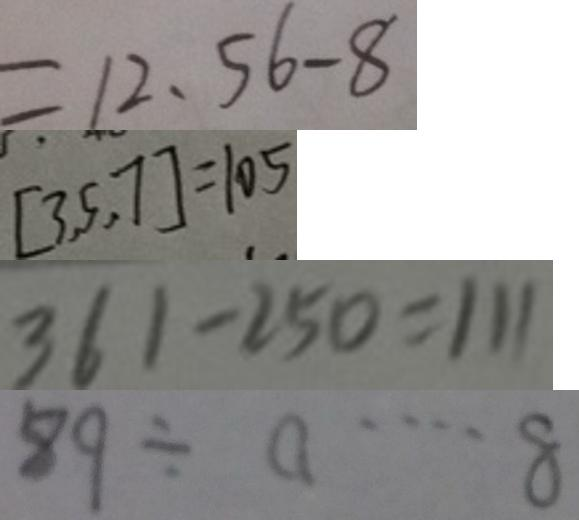<formula> <loc_0><loc_0><loc_500><loc_500>= 1 2 . 5 6 - 8 
 [ 3 , 5 , 7 ] = 1 0 5 
 3 6 1 - 2 5 0 = 1 1 1 
 8 9 \div a \cdots 8</formula> 